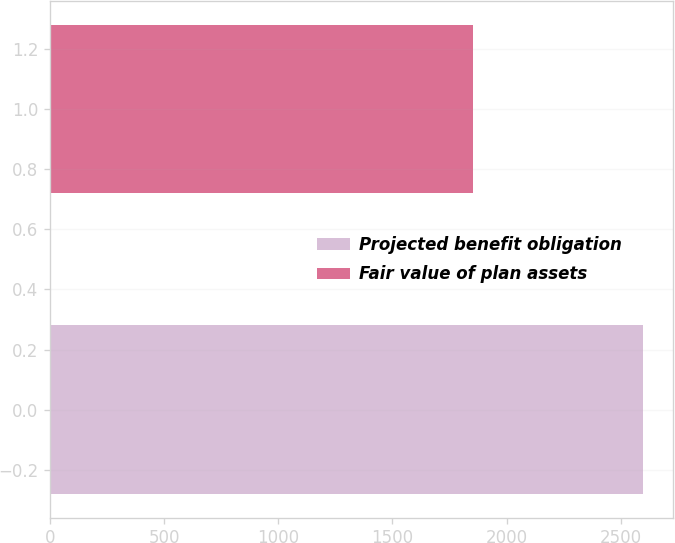Convert chart to OTSL. <chart><loc_0><loc_0><loc_500><loc_500><bar_chart><fcel>Projected benefit obligation<fcel>Fair value of plan assets<nl><fcel>2600<fcel>1853<nl></chart> 